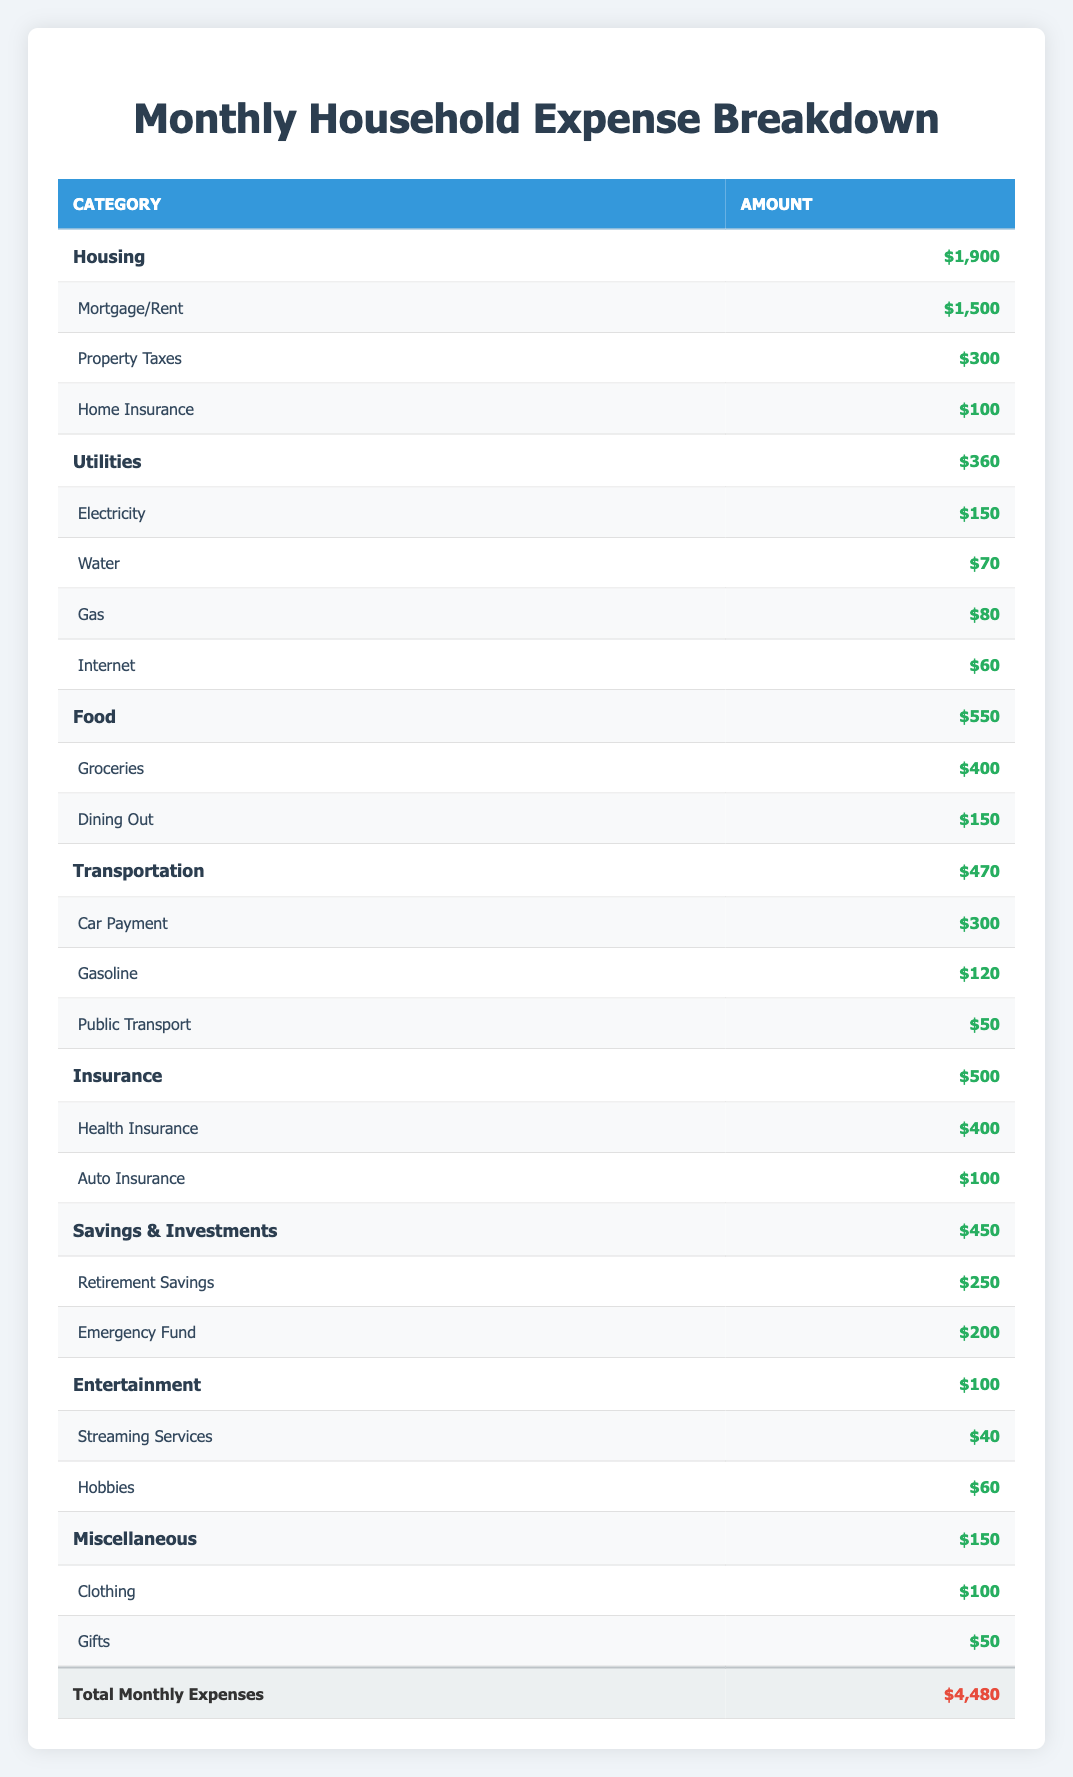What is the total amount spent on Housing? The table shows that the total amount spent on Housing is $1,900, which includes Mortgage/Rent ($1,500), Property Taxes ($300), and Home Insurance ($100).
Answer: 1900 Which category has the highest monthly expense? By comparing the total expenses across each category, Housing has the highest monthly expense at $1,900.
Answer: Housing How much is spent on Utilities compared to Transportation? The Utilities category totals $360 and the Transportation category totals $470. To compare, Transportation has a higher expense: 470 - 360 = 110.
Answer: 110 more What percentage of the total expenses is allocated to Food? First, the total expenses amount to $4,480, and the Food category expenses total $550. To find the percentage: (550 / 4480) * 100 ≈ 12.3%.
Answer: Approximately 12.3% Is the total amount spent on Entertainment greater than that on Miscellaneous? The Entertainment category totals $100 while the Miscellaneous category totals $150. Since 100 is less than 150, the statement is false.
Answer: No How much more is spent on Savings & Investments than on Entertainment? Savings & Investments total $450 while Entertainment totals $100. The difference is calculated as 450 - 100 = 350.
Answer: 350 What is the combined total for all types of Insurance? Total Insurance expenses add up: Health Insurance ($400) plus Auto Insurance ($100) equals $500. This value can be verified by checking the amounts in the Insurance category.
Answer: 500 What is the average monthly expense for the Transportation subcategories? The Transportation subcategories include Car Payment ($300), Gasoline ($120), and Public Transport ($50). Adding these gives a total of 470, and with 3 subcategories, the average is 470 / 3 ≈ 156.67.
Answer: Approximately 156.67 How many categories have expenses greater than $400? Reviewing each category shows that Housing ($1,900), Food ($550), Insurance ($500), and Savings & Investments ($450) all exceed $400. This gives a total of four categories.
Answer: 4 